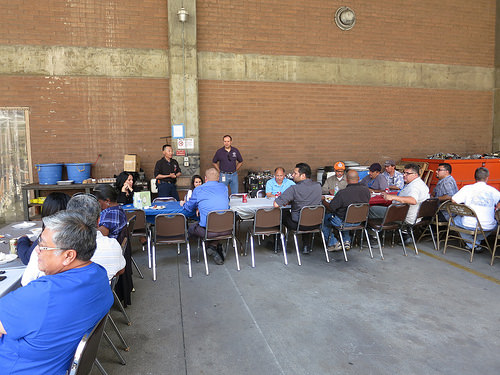<image>
Is there a sitting man in front of the standing man? Yes. The sitting man is positioned in front of the standing man, appearing closer to the camera viewpoint. 